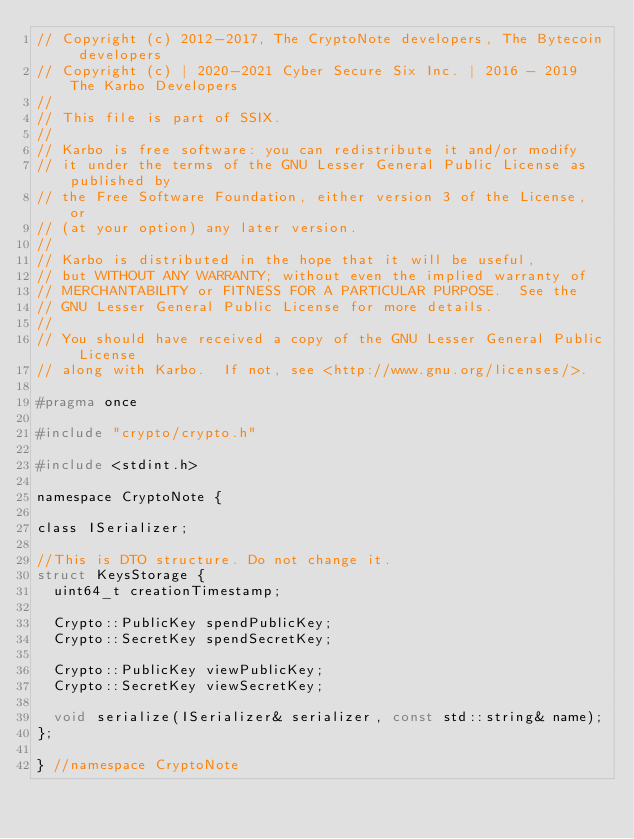<code> <loc_0><loc_0><loc_500><loc_500><_C_>// Copyright (c) 2012-2017, The CryptoNote developers, The Bytecoin developers
// Copyright (c) | 2020-2021 Cyber Secure Six Inc. | 2016 - 2019 The Karbo Developers
//
// This file is part of SSIX.
//
// Karbo is free software: you can redistribute it and/or modify
// it under the terms of the GNU Lesser General Public License as published by
// the Free Software Foundation, either version 3 of the License, or
// (at your option) any later version.
//
// Karbo is distributed in the hope that it will be useful,
// but WITHOUT ANY WARRANTY; without even the implied warranty of
// MERCHANTABILITY or FITNESS FOR A PARTICULAR PURPOSE.  See the
// GNU Lesser General Public License for more details.
//
// You should have received a copy of the GNU Lesser General Public License
// along with Karbo.  If not, see <http://www.gnu.org/licenses/>.

#pragma once

#include "crypto/crypto.h"

#include <stdint.h>

namespace CryptoNote {

class ISerializer;

//This is DTO structure. Do not change it.
struct KeysStorage {
  uint64_t creationTimestamp;

  Crypto::PublicKey spendPublicKey;
  Crypto::SecretKey spendSecretKey;

  Crypto::PublicKey viewPublicKey;
  Crypto::SecretKey viewSecretKey;

  void serialize(ISerializer& serializer, const std::string& name);
};

} //namespace CryptoNote
</code> 